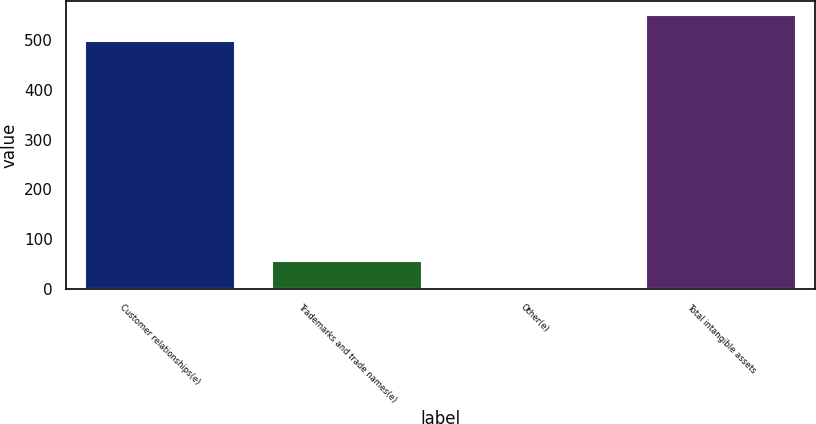<chart> <loc_0><loc_0><loc_500><loc_500><bar_chart><fcel>Customer relationships(e)<fcel>Trademarks and trade names(e)<fcel>Other(e)<fcel>Total intangible assets<nl><fcel>497.8<fcel>57.37<fcel>4.3<fcel>550.87<nl></chart> 